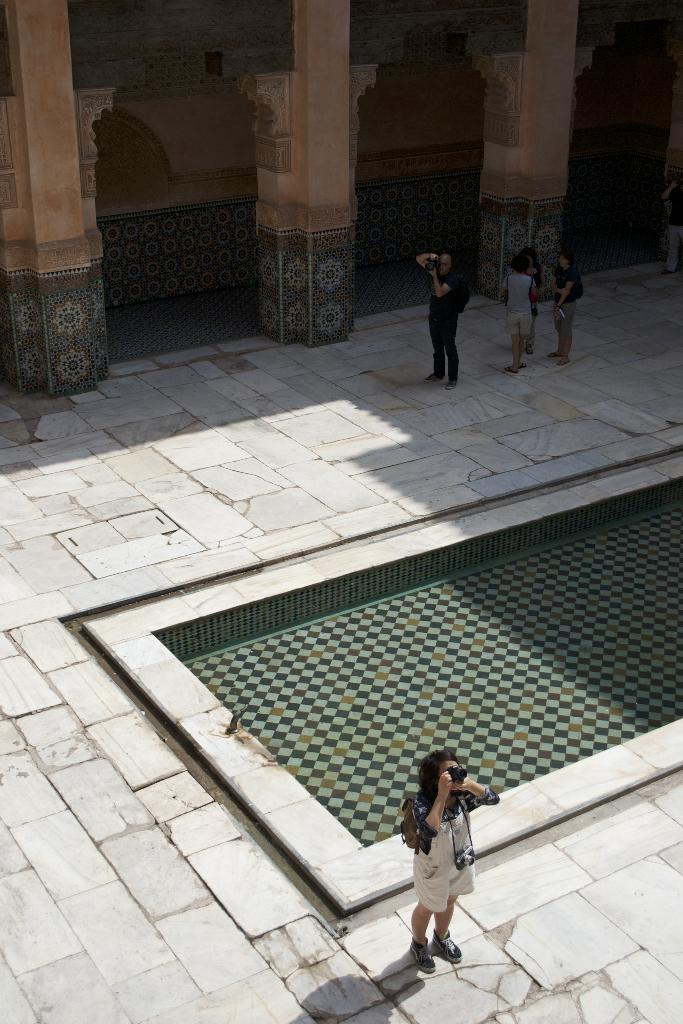What are the people in the image doing? The people in the image are standing on a pavement. What can be seen in the middle of the image? There is a floor in the middle of the image. What architectural features are visible in the background of the image? There are pillars in the background of the image. What objects are the people holding in their hands? Two people are holding cameras in their hands. What type of pear is being used as an example in the image? There is no pear present in the image; it features people standing on a pavement, a floor, pillars, and cameras. 